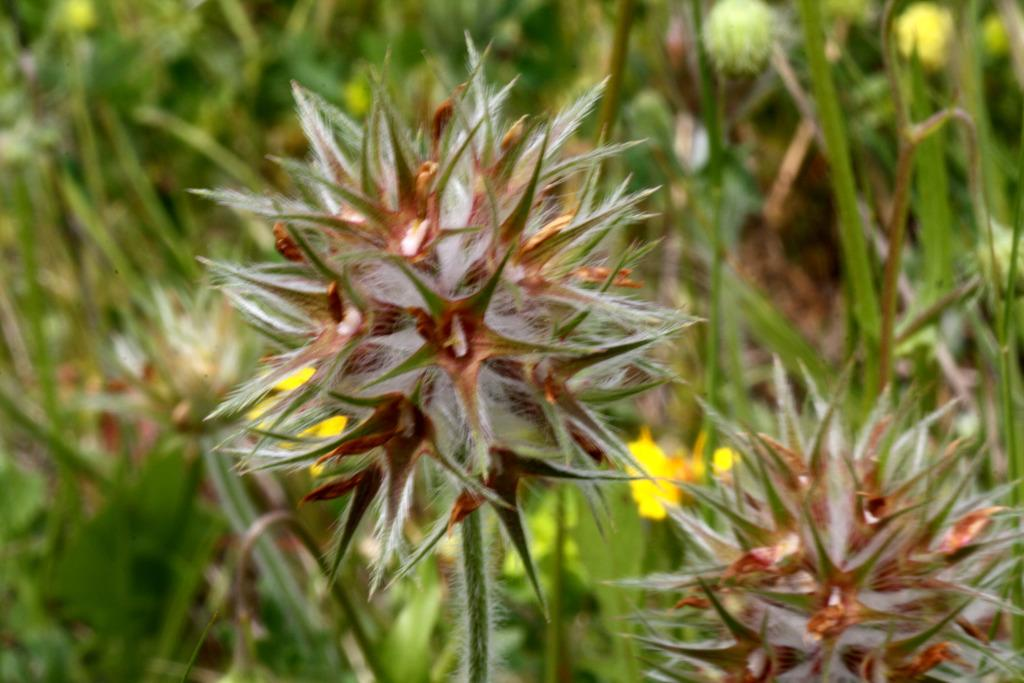What type of plants can be seen in the image? There are flower plants in the image. Can you describe the background of the image? The background of the image is blurred. What type of coach is visible in the image? There is no coach present in the image; it only features flower plants and a blurred background. 